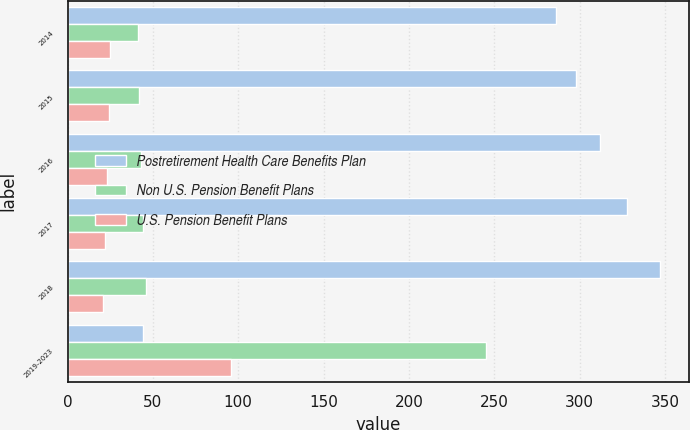Convert chart to OTSL. <chart><loc_0><loc_0><loc_500><loc_500><stacked_bar_chart><ecel><fcel>2014<fcel>2015<fcel>2016<fcel>2017<fcel>2018<fcel>2019-2023<nl><fcel>Postretirement Health Care Benefits Plan<fcel>286<fcel>298<fcel>312<fcel>328<fcel>347<fcel>44<nl><fcel>Non U.S. Pension Benefit Plans<fcel>41<fcel>42<fcel>43<fcel>44<fcel>46<fcel>245<nl><fcel>U.S. Pension Benefit Plans<fcel>25<fcel>24<fcel>23<fcel>22<fcel>21<fcel>96<nl></chart> 